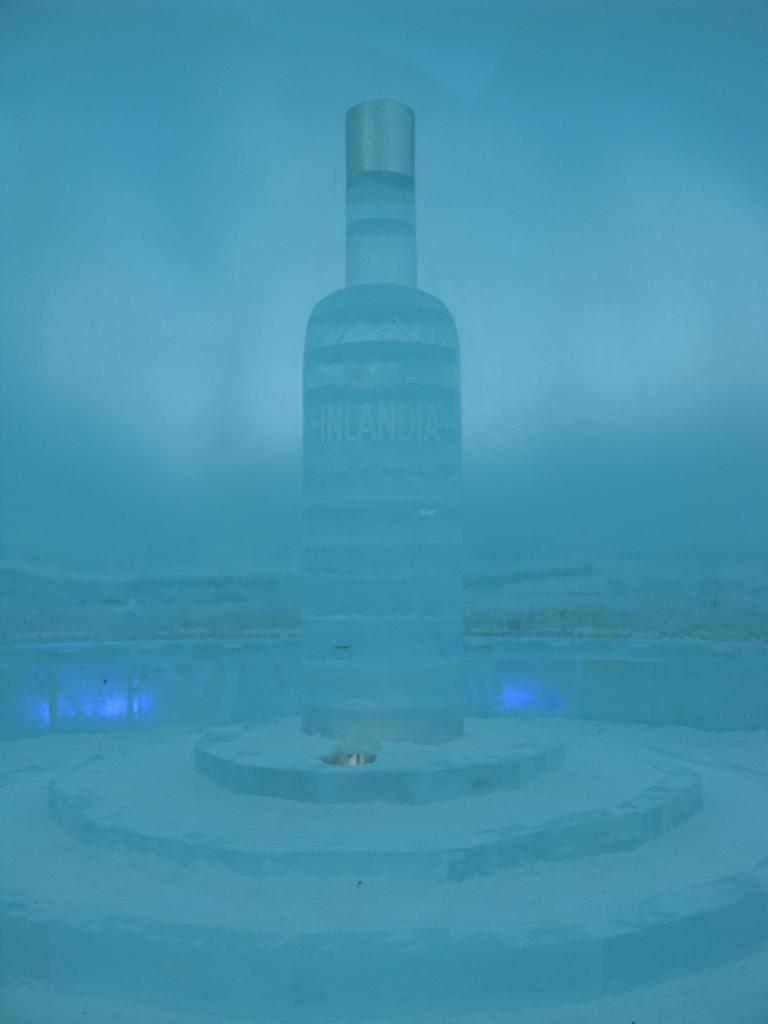What object can be seen in the image? There is a bottle in the image. What color is the background of the image? The background of the image is blue. How many dinosaurs are visible in the image? There are no dinosaurs present in the image. What type of goat can be seen sitting on the table in the image? There is no goat or table present in the image. 